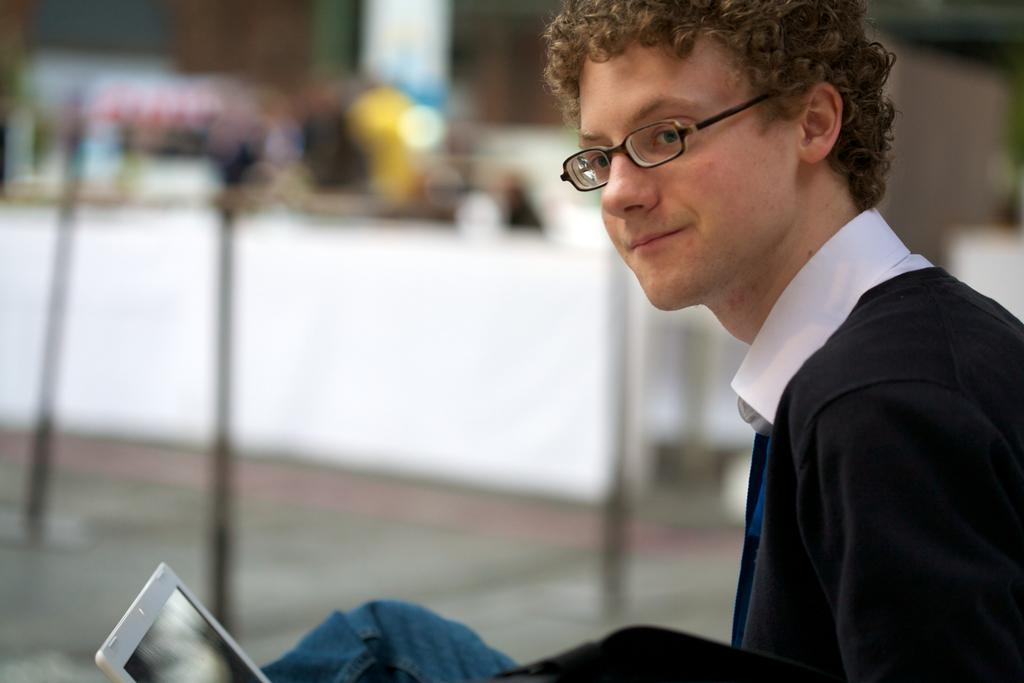What can be seen in the image? There is a person in the image. Can you describe the person's appearance? The person is wearing glasses. What object is present in the image along with the person? There is a laptop in the image. How would you describe the background of the image? The background of the image is blurred. What type of pen is the person holding in the image? There is no pen visible in the image; the person is not holding any pen. Can you describe the person's smile in the image? There is no smile mentioned in the image, and the person's facial expression is not described. 